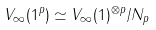Convert formula to latex. <formula><loc_0><loc_0><loc_500><loc_500>V _ { \infty } ( 1 ^ { p } ) \simeq V _ { \infty } ( 1 ) ^ { \otimes p } / N _ { p }</formula> 